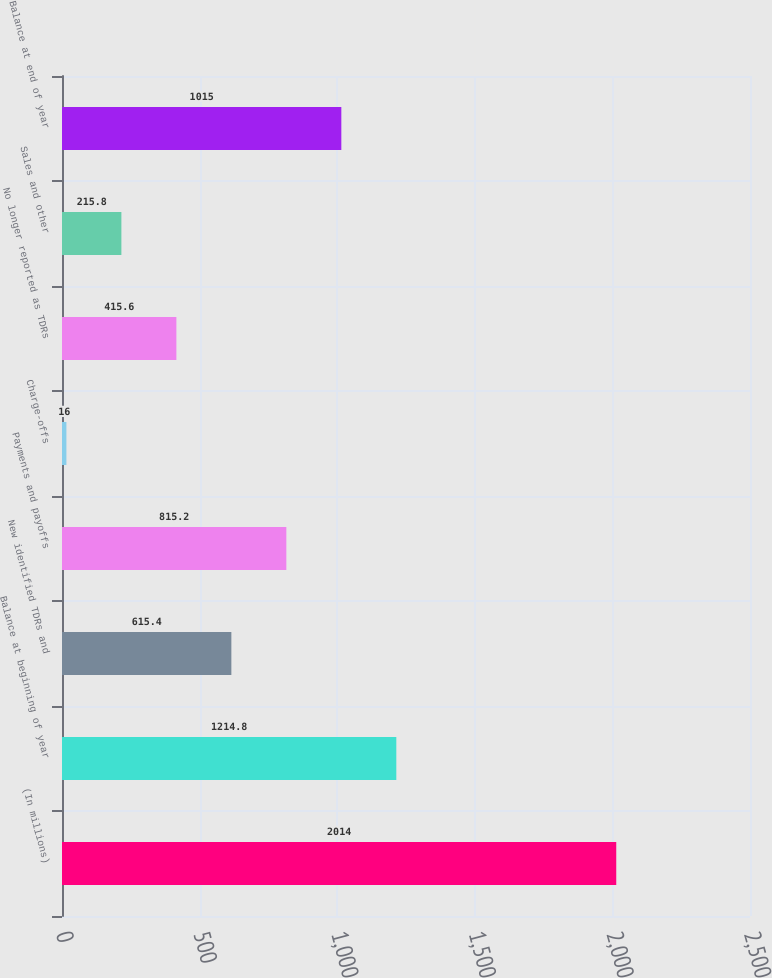<chart> <loc_0><loc_0><loc_500><loc_500><bar_chart><fcel>(In millions)<fcel>Balance at beginning of year<fcel>New identified TDRs and<fcel>Payments and payoffs<fcel>Charge-offs<fcel>No longer reported as TDRs<fcel>Sales and other<fcel>Balance at end of year<nl><fcel>2014<fcel>1214.8<fcel>615.4<fcel>815.2<fcel>16<fcel>415.6<fcel>215.8<fcel>1015<nl></chart> 